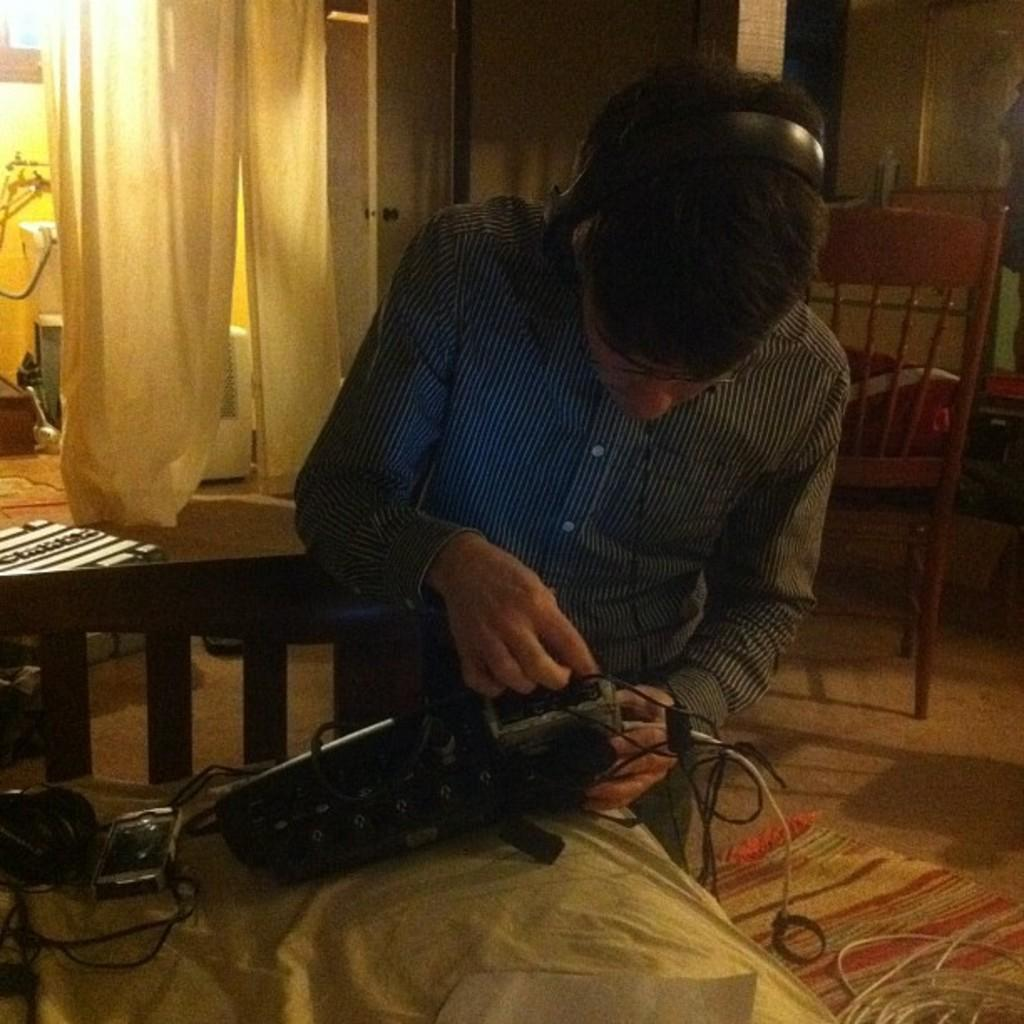What is the main subject of the image? There is a man in the image. What is the man doing in the image? The man is standing and connecting a wire to a machine. Are there any other objects or furniture in the image? Yes, there is a chair in the image. What can be seen hanging in the background of the image? There are curtains hanging in the image. What type of rice is being served to the committee in the image? There is no committee or rice present in the image. The image only shows a man standing and connecting a wire to a machine, with a chair and curtains in the background. 